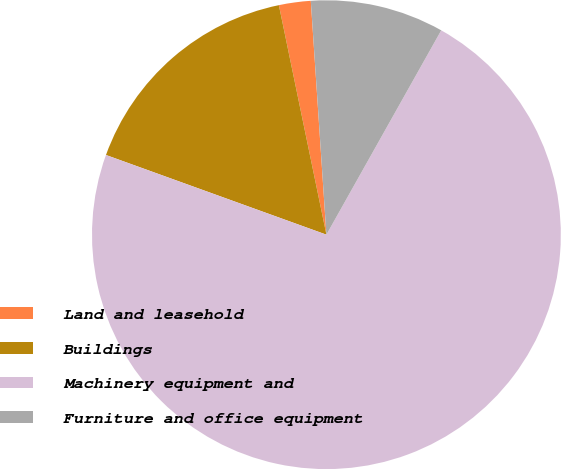Convert chart. <chart><loc_0><loc_0><loc_500><loc_500><pie_chart><fcel>Land and leasehold<fcel>Buildings<fcel>Machinery equipment and<fcel>Furniture and office equipment<nl><fcel>2.19%<fcel>16.23%<fcel>72.38%<fcel>9.21%<nl></chart> 